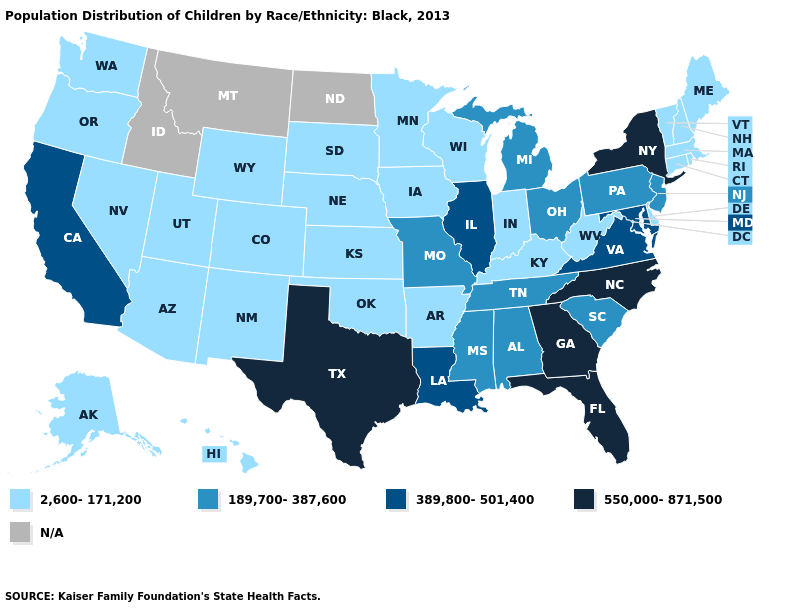Does Hawaii have the highest value in the USA?
Quick response, please. No. Name the states that have a value in the range 2,600-171,200?
Concise answer only. Alaska, Arizona, Arkansas, Colorado, Connecticut, Delaware, Hawaii, Indiana, Iowa, Kansas, Kentucky, Maine, Massachusetts, Minnesota, Nebraska, Nevada, New Hampshire, New Mexico, Oklahoma, Oregon, Rhode Island, South Dakota, Utah, Vermont, Washington, West Virginia, Wisconsin, Wyoming. What is the value of Colorado?
Short answer required. 2,600-171,200. What is the lowest value in states that border Rhode Island?
Quick response, please. 2,600-171,200. Which states have the highest value in the USA?
Quick response, please. Florida, Georgia, New York, North Carolina, Texas. Does Pennsylvania have the lowest value in the Northeast?
Be succinct. No. What is the lowest value in the USA?
Be succinct. 2,600-171,200. What is the highest value in states that border Maine?
Keep it brief. 2,600-171,200. What is the value of Arkansas?
Keep it brief. 2,600-171,200. Name the states that have a value in the range 189,700-387,600?
Answer briefly. Alabama, Michigan, Mississippi, Missouri, New Jersey, Ohio, Pennsylvania, South Carolina, Tennessee. Name the states that have a value in the range 189,700-387,600?
Short answer required. Alabama, Michigan, Mississippi, Missouri, New Jersey, Ohio, Pennsylvania, South Carolina, Tennessee. What is the highest value in the USA?
Keep it brief. 550,000-871,500. Which states hav the highest value in the South?
Keep it brief. Florida, Georgia, North Carolina, Texas. 